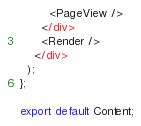<code> <loc_0><loc_0><loc_500><loc_500><_TypeScript_>        <PageView />
      </div>
      <Render />
    </div>
  );
};

export default Content;
</code> 